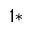<formula> <loc_0><loc_0><loc_500><loc_500>^ { 1 * }</formula> 